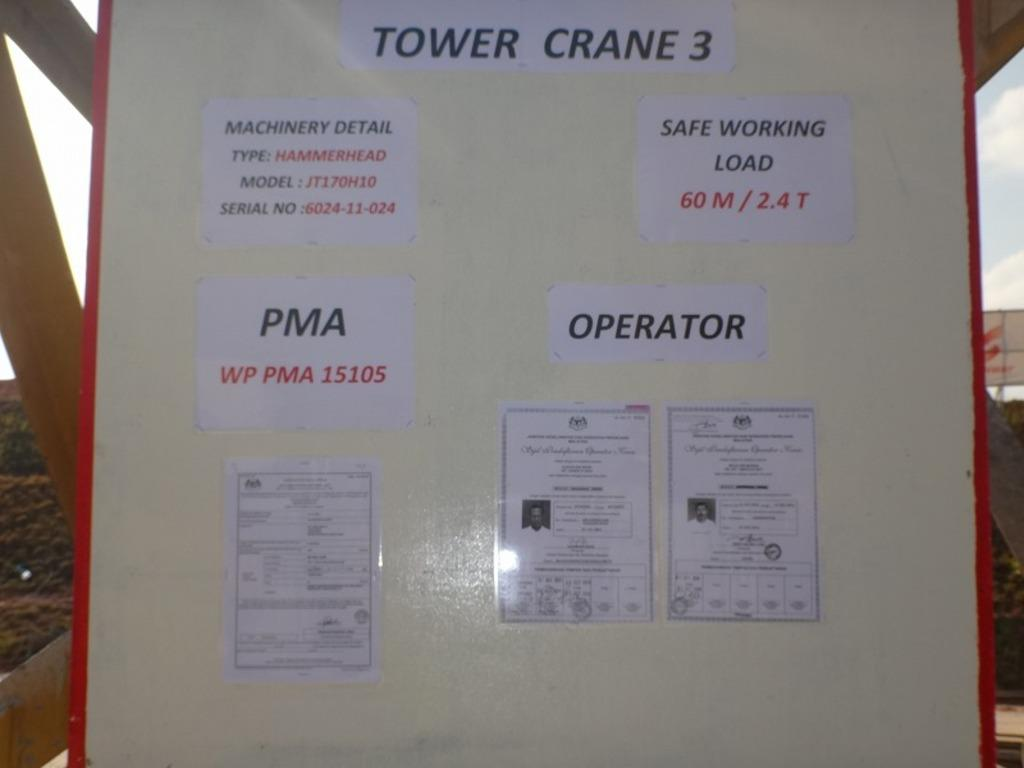<image>
Offer a succinct explanation of the picture presented. A poster that has Tower Crane 3 at the top and a description of the machinery underneath 